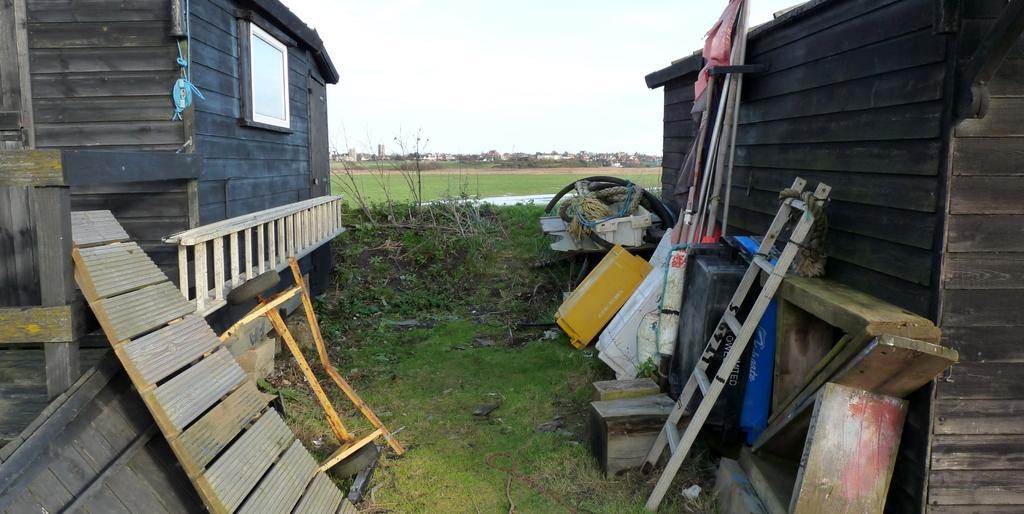How would you summarize this image in a sentence or two? In this image on the right side and left side there are two houses and ladder boxes ropes wooden sticks and pipes and some containers. At the bottom there is grass and some plants, in the background there are some buildings and houses. On the top of the image there is sky. 